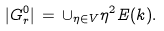<formula> <loc_0><loc_0><loc_500><loc_500>| G _ { r } ^ { 0 } | \, = \, \cup _ { \eta \in V } \eta ^ { 2 } E ( k ) .</formula> 